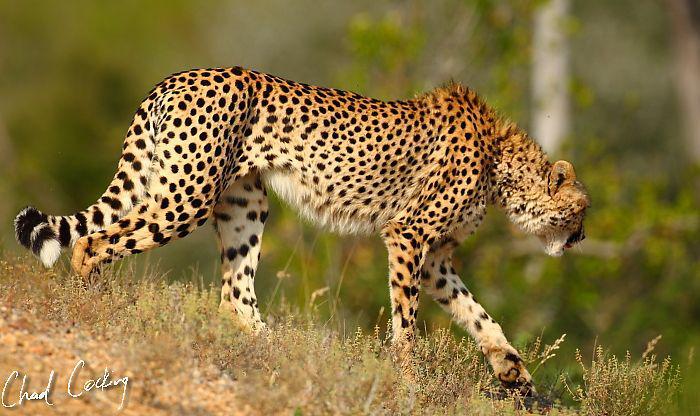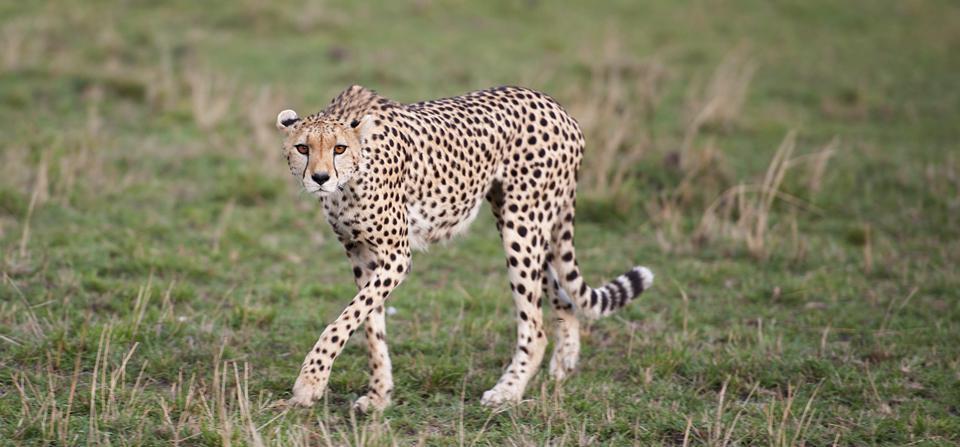The first image is the image on the left, the second image is the image on the right. Considering the images on both sides, is "One image features one cheetah bounding forward." valid? Answer yes or no. No. 